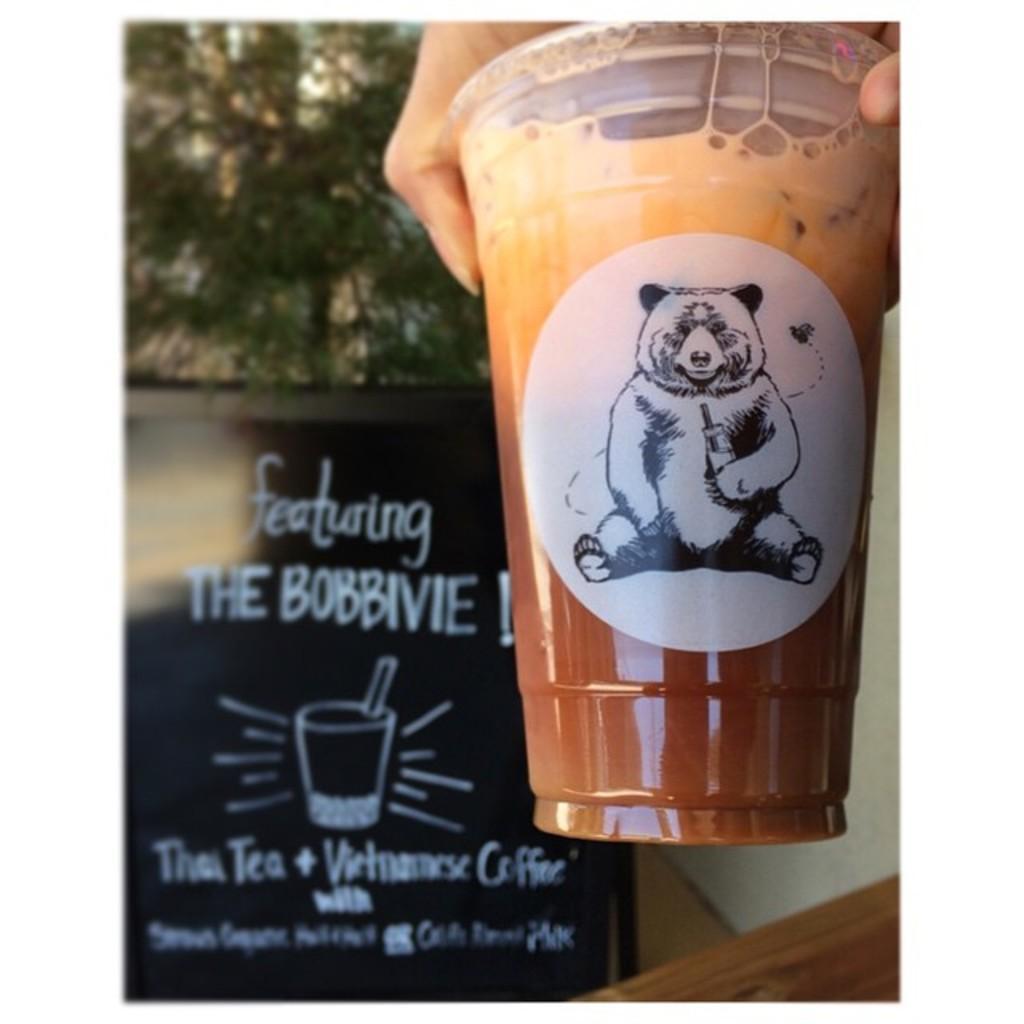In one or two sentences, can you explain what this image depicts? In this image we can see a person's hand holding a cup. In the background there is a board and a tree. 